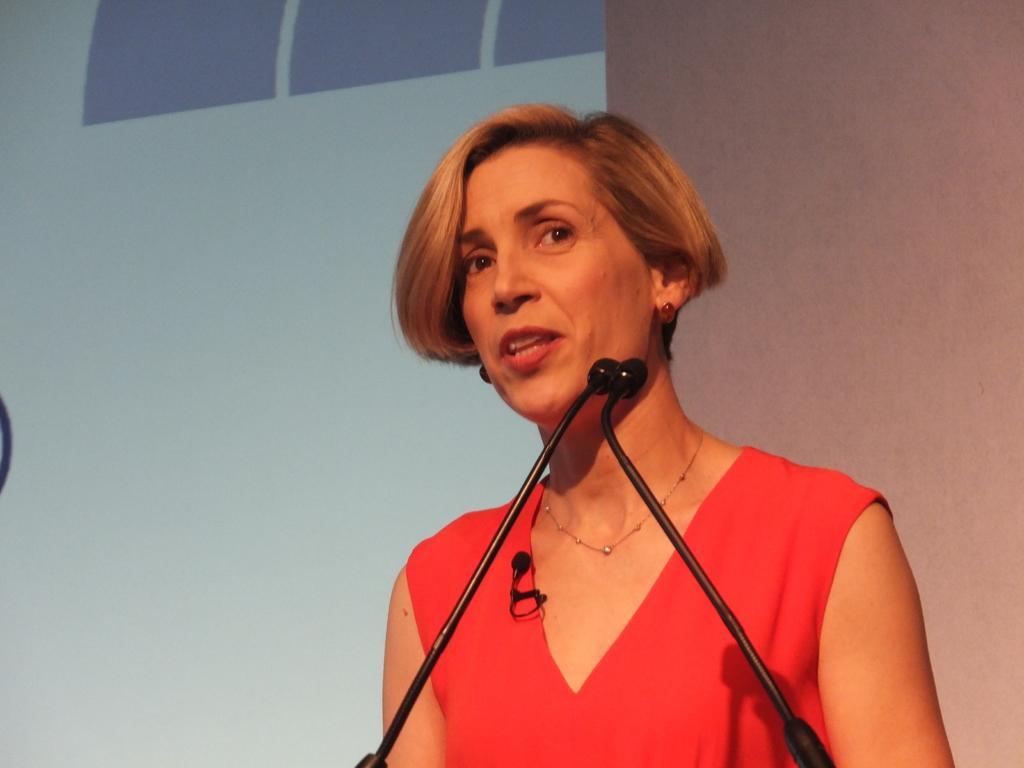In one or two sentences, can you explain what this image depicts? In this image we can see a woman. She is wearing a red color top and jewelry. In front of her, we can see mics. In the background, we can see a wall and screen. 